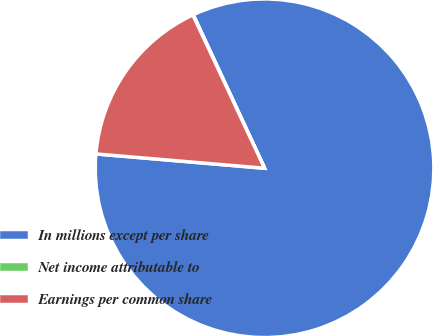Convert chart to OTSL. <chart><loc_0><loc_0><loc_500><loc_500><pie_chart><fcel>In millions except per share<fcel>Net income attributable to<fcel>Earnings per common share<nl><fcel>83.27%<fcel>0.04%<fcel>16.69%<nl></chart> 